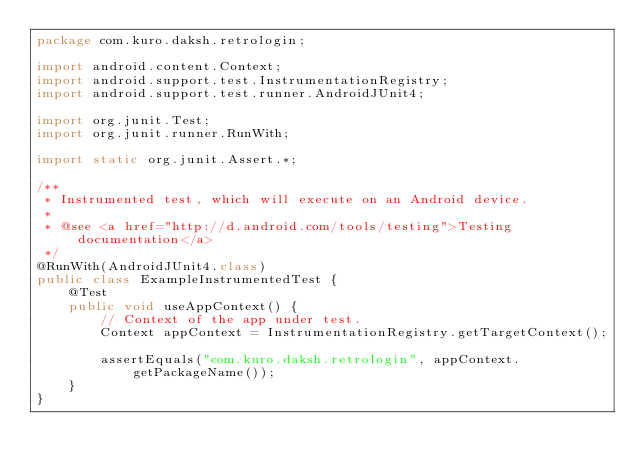Convert code to text. <code><loc_0><loc_0><loc_500><loc_500><_Java_>package com.kuro.daksh.retrologin;

import android.content.Context;
import android.support.test.InstrumentationRegistry;
import android.support.test.runner.AndroidJUnit4;

import org.junit.Test;
import org.junit.runner.RunWith;

import static org.junit.Assert.*;

/**
 * Instrumented test, which will execute on an Android device.
 *
 * @see <a href="http://d.android.com/tools/testing">Testing documentation</a>
 */
@RunWith(AndroidJUnit4.class)
public class ExampleInstrumentedTest {
    @Test
    public void useAppContext() {
        // Context of the app under test.
        Context appContext = InstrumentationRegistry.getTargetContext();

        assertEquals("com.kuro.daksh.retrologin", appContext.getPackageName());
    }
}
</code> 